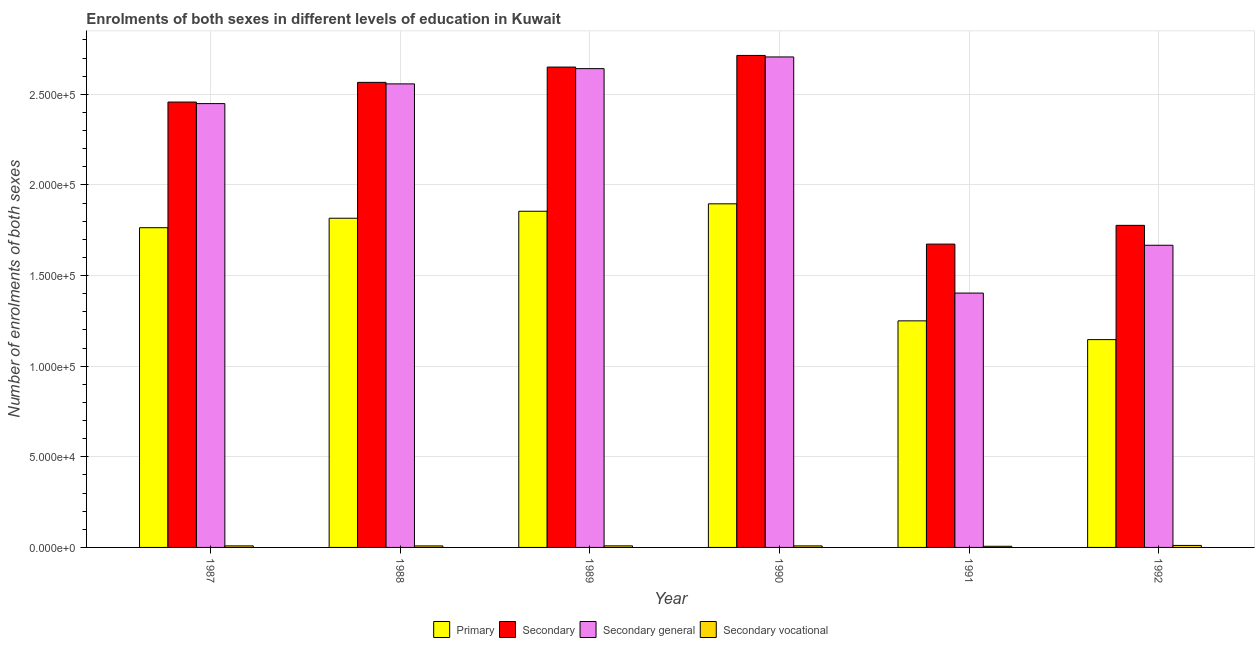Are the number of bars per tick equal to the number of legend labels?
Provide a short and direct response. Yes. What is the label of the 3rd group of bars from the left?
Your answer should be very brief. 1989. What is the number of enrolments in secondary general education in 1992?
Provide a short and direct response. 1.67e+05. Across all years, what is the maximum number of enrolments in secondary education?
Offer a very short reply. 2.71e+05. Across all years, what is the minimum number of enrolments in secondary education?
Keep it short and to the point. 1.67e+05. In which year was the number of enrolments in secondary vocational education maximum?
Your answer should be compact. 1992. In which year was the number of enrolments in secondary vocational education minimum?
Provide a succinct answer. 1991. What is the total number of enrolments in secondary general education in the graph?
Keep it short and to the point. 1.34e+06. What is the difference between the number of enrolments in secondary general education in 1987 and that in 1990?
Your answer should be very brief. -2.57e+04. What is the difference between the number of enrolments in secondary general education in 1991 and the number of enrolments in secondary education in 1987?
Provide a succinct answer. -1.05e+05. What is the average number of enrolments in secondary vocational education per year?
Ensure brevity in your answer.  855.33. What is the ratio of the number of enrolments in secondary vocational education in 1987 to that in 1991?
Provide a short and direct response. 1.35. Is the number of enrolments in secondary general education in 1987 less than that in 1989?
Make the answer very short. Yes. Is the difference between the number of enrolments in secondary education in 1988 and 1989 greater than the difference between the number of enrolments in primary education in 1988 and 1989?
Provide a short and direct response. No. What is the difference between the highest and the second highest number of enrolments in primary education?
Your response must be concise. 4096. What is the difference between the highest and the lowest number of enrolments in secondary education?
Provide a short and direct response. 1.04e+05. Is the sum of the number of enrolments in secondary general education in 1991 and 1992 greater than the maximum number of enrolments in secondary education across all years?
Make the answer very short. Yes. Is it the case that in every year, the sum of the number of enrolments in secondary vocational education and number of enrolments in primary education is greater than the sum of number of enrolments in secondary education and number of enrolments in secondary general education?
Offer a terse response. No. What does the 4th bar from the left in 1992 represents?
Your response must be concise. Secondary vocational. What does the 3rd bar from the right in 1988 represents?
Give a very brief answer. Secondary. Is it the case that in every year, the sum of the number of enrolments in primary education and number of enrolments in secondary education is greater than the number of enrolments in secondary general education?
Make the answer very short. Yes. Are all the bars in the graph horizontal?
Keep it short and to the point. No. What is the title of the graph?
Make the answer very short. Enrolments of both sexes in different levels of education in Kuwait. What is the label or title of the X-axis?
Your response must be concise. Year. What is the label or title of the Y-axis?
Provide a short and direct response. Number of enrolments of both sexes. What is the Number of enrolments of both sexes of Primary in 1987?
Provide a short and direct response. 1.76e+05. What is the Number of enrolments of both sexes of Secondary in 1987?
Give a very brief answer. 2.46e+05. What is the Number of enrolments of both sexes of Secondary general in 1987?
Make the answer very short. 2.45e+05. What is the Number of enrolments of both sexes of Secondary vocational in 1987?
Give a very brief answer. 854. What is the Number of enrolments of both sexes of Primary in 1988?
Your answer should be very brief. 1.82e+05. What is the Number of enrolments of both sexes of Secondary in 1988?
Offer a terse response. 2.57e+05. What is the Number of enrolments of both sexes in Secondary general in 1988?
Offer a terse response. 2.56e+05. What is the Number of enrolments of both sexes in Secondary vocational in 1988?
Make the answer very short. 836. What is the Number of enrolments of both sexes in Primary in 1989?
Offer a very short reply. 1.85e+05. What is the Number of enrolments of both sexes in Secondary in 1989?
Make the answer very short. 2.65e+05. What is the Number of enrolments of both sexes of Secondary general in 1989?
Offer a very short reply. 2.64e+05. What is the Number of enrolments of both sexes of Secondary vocational in 1989?
Your answer should be very brief. 863. What is the Number of enrolments of both sexes of Primary in 1990?
Your answer should be compact. 1.90e+05. What is the Number of enrolments of both sexes in Secondary in 1990?
Provide a short and direct response. 2.71e+05. What is the Number of enrolments of both sexes in Secondary general in 1990?
Provide a succinct answer. 2.71e+05. What is the Number of enrolments of both sexes of Secondary vocational in 1990?
Provide a succinct answer. 842. What is the Number of enrolments of both sexes of Primary in 1991?
Keep it short and to the point. 1.25e+05. What is the Number of enrolments of both sexes of Secondary in 1991?
Your response must be concise. 1.67e+05. What is the Number of enrolments of both sexes of Secondary general in 1991?
Make the answer very short. 1.40e+05. What is the Number of enrolments of both sexes of Secondary vocational in 1991?
Provide a succinct answer. 634. What is the Number of enrolments of both sexes of Primary in 1992?
Offer a terse response. 1.15e+05. What is the Number of enrolments of both sexes of Secondary in 1992?
Make the answer very short. 1.78e+05. What is the Number of enrolments of both sexes of Secondary general in 1992?
Ensure brevity in your answer.  1.67e+05. What is the Number of enrolments of both sexes in Secondary vocational in 1992?
Make the answer very short. 1103. Across all years, what is the maximum Number of enrolments of both sexes in Primary?
Your answer should be compact. 1.90e+05. Across all years, what is the maximum Number of enrolments of both sexes of Secondary?
Give a very brief answer. 2.71e+05. Across all years, what is the maximum Number of enrolments of both sexes in Secondary general?
Your response must be concise. 2.71e+05. Across all years, what is the maximum Number of enrolments of both sexes in Secondary vocational?
Give a very brief answer. 1103. Across all years, what is the minimum Number of enrolments of both sexes of Primary?
Provide a succinct answer. 1.15e+05. Across all years, what is the minimum Number of enrolments of both sexes in Secondary?
Give a very brief answer. 1.67e+05. Across all years, what is the minimum Number of enrolments of both sexes of Secondary general?
Make the answer very short. 1.40e+05. Across all years, what is the minimum Number of enrolments of both sexes in Secondary vocational?
Ensure brevity in your answer.  634. What is the total Number of enrolments of both sexes in Primary in the graph?
Your response must be concise. 9.73e+05. What is the total Number of enrolments of both sexes of Secondary in the graph?
Provide a short and direct response. 1.38e+06. What is the total Number of enrolments of both sexes in Secondary general in the graph?
Your answer should be very brief. 1.34e+06. What is the total Number of enrolments of both sexes in Secondary vocational in the graph?
Make the answer very short. 5132. What is the difference between the Number of enrolments of both sexes of Primary in 1987 and that in 1988?
Keep it short and to the point. -5229. What is the difference between the Number of enrolments of both sexes of Secondary in 1987 and that in 1988?
Offer a very short reply. -1.09e+04. What is the difference between the Number of enrolments of both sexes in Secondary general in 1987 and that in 1988?
Provide a short and direct response. -1.09e+04. What is the difference between the Number of enrolments of both sexes in Secondary vocational in 1987 and that in 1988?
Offer a terse response. 18. What is the difference between the Number of enrolments of both sexes of Primary in 1987 and that in 1989?
Provide a succinct answer. -9086. What is the difference between the Number of enrolments of both sexes in Secondary in 1987 and that in 1989?
Offer a very short reply. -1.93e+04. What is the difference between the Number of enrolments of both sexes in Secondary general in 1987 and that in 1989?
Provide a succinct answer. -1.93e+04. What is the difference between the Number of enrolments of both sexes in Primary in 1987 and that in 1990?
Keep it short and to the point. -1.32e+04. What is the difference between the Number of enrolments of both sexes of Secondary in 1987 and that in 1990?
Your answer should be compact. -2.57e+04. What is the difference between the Number of enrolments of both sexes of Secondary general in 1987 and that in 1990?
Provide a short and direct response. -2.57e+04. What is the difference between the Number of enrolments of both sexes in Secondary vocational in 1987 and that in 1990?
Provide a succinct answer. 12. What is the difference between the Number of enrolments of both sexes in Primary in 1987 and that in 1991?
Make the answer very short. 5.14e+04. What is the difference between the Number of enrolments of both sexes of Secondary in 1987 and that in 1991?
Your response must be concise. 7.84e+04. What is the difference between the Number of enrolments of both sexes in Secondary general in 1987 and that in 1991?
Ensure brevity in your answer.  1.05e+05. What is the difference between the Number of enrolments of both sexes in Secondary vocational in 1987 and that in 1991?
Your answer should be very brief. 220. What is the difference between the Number of enrolments of both sexes of Primary in 1987 and that in 1992?
Ensure brevity in your answer.  6.17e+04. What is the difference between the Number of enrolments of both sexes of Secondary in 1987 and that in 1992?
Ensure brevity in your answer.  6.80e+04. What is the difference between the Number of enrolments of both sexes of Secondary general in 1987 and that in 1992?
Ensure brevity in your answer.  7.81e+04. What is the difference between the Number of enrolments of both sexes of Secondary vocational in 1987 and that in 1992?
Ensure brevity in your answer.  -249. What is the difference between the Number of enrolments of both sexes in Primary in 1988 and that in 1989?
Offer a terse response. -3857. What is the difference between the Number of enrolments of both sexes in Secondary in 1988 and that in 1989?
Offer a terse response. -8443. What is the difference between the Number of enrolments of both sexes in Secondary general in 1988 and that in 1989?
Offer a terse response. -8416. What is the difference between the Number of enrolments of both sexes in Primary in 1988 and that in 1990?
Keep it short and to the point. -7953. What is the difference between the Number of enrolments of both sexes in Secondary in 1988 and that in 1990?
Your answer should be compact. -1.49e+04. What is the difference between the Number of enrolments of both sexes of Secondary general in 1988 and that in 1990?
Ensure brevity in your answer.  -1.49e+04. What is the difference between the Number of enrolments of both sexes in Primary in 1988 and that in 1991?
Your answer should be compact. 5.66e+04. What is the difference between the Number of enrolments of both sexes of Secondary in 1988 and that in 1991?
Ensure brevity in your answer.  8.92e+04. What is the difference between the Number of enrolments of both sexes in Secondary general in 1988 and that in 1991?
Offer a very short reply. 1.15e+05. What is the difference between the Number of enrolments of both sexes of Secondary vocational in 1988 and that in 1991?
Provide a short and direct response. 202. What is the difference between the Number of enrolments of both sexes in Primary in 1988 and that in 1992?
Give a very brief answer. 6.70e+04. What is the difference between the Number of enrolments of both sexes in Secondary in 1988 and that in 1992?
Give a very brief answer. 7.89e+04. What is the difference between the Number of enrolments of both sexes in Secondary general in 1988 and that in 1992?
Offer a terse response. 8.90e+04. What is the difference between the Number of enrolments of both sexes in Secondary vocational in 1988 and that in 1992?
Offer a terse response. -267. What is the difference between the Number of enrolments of both sexes in Primary in 1989 and that in 1990?
Ensure brevity in your answer.  -4096. What is the difference between the Number of enrolments of both sexes in Secondary in 1989 and that in 1990?
Your answer should be compact. -6421. What is the difference between the Number of enrolments of both sexes in Secondary general in 1989 and that in 1990?
Offer a terse response. -6442. What is the difference between the Number of enrolments of both sexes in Secondary vocational in 1989 and that in 1990?
Provide a succinct answer. 21. What is the difference between the Number of enrolments of both sexes in Primary in 1989 and that in 1991?
Ensure brevity in your answer.  6.05e+04. What is the difference between the Number of enrolments of both sexes of Secondary in 1989 and that in 1991?
Make the answer very short. 9.77e+04. What is the difference between the Number of enrolments of both sexes in Secondary general in 1989 and that in 1991?
Your answer should be compact. 1.24e+05. What is the difference between the Number of enrolments of both sexes of Secondary vocational in 1989 and that in 1991?
Offer a very short reply. 229. What is the difference between the Number of enrolments of both sexes in Primary in 1989 and that in 1992?
Your answer should be compact. 7.08e+04. What is the difference between the Number of enrolments of both sexes in Secondary in 1989 and that in 1992?
Make the answer very short. 8.73e+04. What is the difference between the Number of enrolments of both sexes of Secondary general in 1989 and that in 1992?
Offer a terse response. 9.74e+04. What is the difference between the Number of enrolments of both sexes in Secondary vocational in 1989 and that in 1992?
Provide a succinct answer. -240. What is the difference between the Number of enrolments of both sexes of Primary in 1990 and that in 1991?
Offer a terse response. 6.46e+04. What is the difference between the Number of enrolments of both sexes in Secondary in 1990 and that in 1991?
Your response must be concise. 1.04e+05. What is the difference between the Number of enrolments of both sexes in Secondary general in 1990 and that in 1991?
Ensure brevity in your answer.  1.30e+05. What is the difference between the Number of enrolments of both sexes of Secondary vocational in 1990 and that in 1991?
Ensure brevity in your answer.  208. What is the difference between the Number of enrolments of both sexes in Primary in 1990 and that in 1992?
Your response must be concise. 7.49e+04. What is the difference between the Number of enrolments of both sexes of Secondary in 1990 and that in 1992?
Your answer should be very brief. 9.37e+04. What is the difference between the Number of enrolments of both sexes in Secondary general in 1990 and that in 1992?
Your response must be concise. 1.04e+05. What is the difference between the Number of enrolments of both sexes in Secondary vocational in 1990 and that in 1992?
Offer a very short reply. -261. What is the difference between the Number of enrolments of both sexes of Primary in 1991 and that in 1992?
Ensure brevity in your answer.  1.04e+04. What is the difference between the Number of enrolments of both sexes in Secondary in 1991 and that in 1992?
Keep it short and to the point. -1.03e+04. What is the difference between the Number of enrolments of both sexes of Secondary general in 1991 and that in 1992?
Give a very brief answer. -2.64e+04. What is the difference between the Number of enrolments of both sexes of Secondary vocational in 1991 and that in 1992?
Your answer should be compact. -469. What is the difference between the Number of enrolments of both sexes in Primary in 1987 and the Number of enrolments of both sexes in Secondary in 1988?
Your answer should be compact. -8.02e+04. What is the difference between the Number of enrolments of both sexes in Primary in 1987 and the Number of enrolments of both sexes in Secondary general in 1988?
Your answer should be compact. -7.93e+04. What is the difference between the Number of enrolments of both sexes of Primary in 1987 and the Number of enrolments of both sexes of Secondary vocational in 1988?
Give a very brief answer. 1.76e+05. What is the difference between the Number of enrolments of both sexes of Secondary in 1987 and the Number of enrolments of both sexes of Secondary general in 1988?
Ensure brevity in your answer.  -1.00e+04. What is the difference between the Number of enrolments of both sexes of Secondary in 1987 and the Number of enrolments of both sexes of Secondary vocational in 1988?
Offer a very short reply. 2.45e+05. What is the difference between the Number of enrolments of both sexes in Secondary general in 1987 and the Number of enrolments of both sexes in Secondary vocational in 1988?
Offer a terse response. 2.44e+05. What is the difference between the Number of enrolments of both sexes of Primary in 1987 and the Number of enrolments of both sexes of Secondary in 1989?
Make the answer very short. -8.86e+04. What is the difference between the Number of enrolments of both sexes of Primary in 1987 and the Number of enrolments of both sexes of Secondary general in 1989?
Provide a short and direct response. -8.78e+04. What is the difference between the Number of enrolments of both sexes of Primary in 1987 and the Number of enrolments of both sexes of Secondary vocational in 1989?
Ensure brevity in your answer.  1.76e+05. What is the difference between the Number of enrolments of both sexes of Secondary in 1987 and the Number of enrolments of both sexes of Secondary general in 1989?
Offer a terse response. -1.84e+04. What is the difference between the Number of enrolments of both sexes of Secondary in 1987 and the Number of enrolments of both sexes of Secondary vocational in 1989?
Offer a terse response. 2.45e+05. What is the difference between the Number of enrolments of both sexes in Secondary general in 1987 and the Number of enrolments of both sexes in Secondary vocational in 1989?
Provide a short and direct response. 2.44e+05. What is the difference between the Number of enrolments of both sexes in Primary in 1987 and the Number of enrolments of both sexes in Secondary in 1990?
Provide a succinct answer. -9.50e+04. What is the difference between the Number of enrolments of both sexes in Primary in 1987 and the Number of enrolments of both sexes in Secondary general in 1990?
Provide a short and direct response. -9.42e+04. What is the difference between the Number of enrolments of both sexes of Primary in 1987 and the Number of enrolments of both sexes of Secondary vocational in 1990?
Your answer should be very brief. 1.76e+05. What is the difference between the Number of enrolments of both sexes of Secondary in 1987 and the Number of enrolments of both sexes of Secondary general in 1990?
Your answer should be very brief. -2.49e+04. What is the difference between the Number of enrolments of both sexes in Secondary in 1987 and the Number of enrolments of both sexes in Secondary vocational in 1990?
Your answer should be compact. 2.45e+05. What is the difference between the Number of enrolments of both sexes in Secondary general in 1987 and the Number of enrolments of both sexes in Secondary vocational in 1990?
Your response must be concise. 2.44e+05. What is the difference between the Number of enrolments of both sexes in Primary in 1987 and the Number of enrolments of both sexes in Secondary in 1991?
Your response must be concise. 9047. What is the difference between the Number of enrolments of both sexes of Primary in 1987 and the Number of enrolments of both sexes of Secondary general in 1991?
Give a very brief answer. 3.61e+04. What is the difference between the Number of enrolments of both sexes in Primary in 1987 and the Number of enrolments of both sexes in Secondary vocational in 1991?
Your answer should be compact. 1.76e+05. What is the difference between the Number of enrolments of both sexes of Secondary in 1987 and the Number of enrolments of both sexes of Secondary general in 1991?
Give a very brief answer. 1.05e+05. What is the difference between the Number of enrolments of both sexes in Secondary in 1987 and the Number of enrolments of both sexes in Secondary vocational in 1991?
Keep it short and to the point. 2.45e+05. What is the difference between the Number of enrolments of both sexes in Secondary general in 1987 and the Number of enrolments of both sexes in Secondary vocational in 1991?
Make the answer very short. 2.44e+05. What is the difference between the Number of enrolments of both sexes in Primary in 1987 and the Number of enrolments of both sexes in Secondary in 1992?
Provide a succinct answer. -1297. What is the difference between the Number of enrolments of both sexes of Primary in 1987 and the Number of enrolments of both sexes of Secondary general in 1992?
Offer a very short reply. 9681. What is the difference between the Number of enrolments of both sexes of Primary in 1987 and the Number of enrolments of both sexes of Secondary vocational in 1992?
Provide a short and direct response. 1.75e+05. What is the difference between the Number of enrolments of both sexes in Secondary in 1987 and the Number of enrolments of both sexes in Secondary general in 1992?
Ensure brevity in your answer.  7.90e+04. What is the difference between the Number of enrolments of both sexes of Secondary in 1987 and the Number of enrolments of both sexes of Secondary vocational in 1992?
Your answer should be very brief. 2.45e+05. What is the difference between the Number of enrolments of both sexes in Secondary general in 1987 and the Number of enrolments of both sexes in Secondary vocational in 1992?
Give a very brief answer. 2.44e+05. What is the difference between the Number of enrolments of both sexes of Primary in 1988 and the Number of enrolments of both sexes of Secondary in 1989?
Ensure brevity in your answer.  -8.34e+04. What is the difference between the Number of enrolments of both sexes of Primary in 1988 and the Number of enrolments of both sexes of Secondary general in 1989?
Keep it short and to the point. -8.25e+04. What is the difference between the Number of enrolments of both sexes in Primary in 1988 and the Number of enrolments of both sexes in Secondary vocational in 1989?
Make the answer very short. 1.81e+05. What is the difference between the Number of enrolments of both sexes in Secondary in 1988 and the Number of enrolments of both sexes in Secondary general in 1989?
Offer a very short reply. -7580. What is the difference between the Number of enrolments of both sexes of Secondary in 1988 and the Number of enrolments of both sexes of Secondary vocational in 1989?
Provide a succinct answer. 2.56e+05. What is the difference between the Number of enrolments of both sexes in Secondary general in 1988 and the Number of enrolments of both sexes in Secondary vocational in 1989?
Your answer should be compact. 2.55e+05. What is the difference between the Number of enrolments of both sexes of Primary in 1988 and the Number of enrolments of both sexes of Secondary in 1990?
Offer a very short reply. -8.98e+04. What is the difference between the Number of enrolments of both sexes in Primary in 1988 and the Number of enrolments of both sexes in Secondary general in 1990?
Give a very brief answer. -8.90e+04. What is the difference between the Number of enrolments of both sexes of Primary in 1988 and the Number of enrolments of both sexes of Secondary vocational in 1990?
Your response must be concise. 1.81e+05. What is the difference between the Number of enrolments of both sexes of Secondary in 1988 and the Number of enrolments of both sexes of Secondary general in 1990?
Offer a very short reply. -1.40e+04. What is the difference between the Number of enrolments of both sexes in Secondary in 1988 and the Number of enrolments of both sexes in Secondary vocational in 1990?
Provide a short and direct response. 2.56e+05. What is the difference between the Number of enrolments of both sexes in Secondary general in 1988 and the Number of enrolments of both sexes in Secondary vocational in 1990?
Provide a succinct answer. 2.55e+05. What is the difference between the Number of enrolments of both sexes of Primary in 1988 and the Number of enrolments of both sexes of Secondary in 1991?
Make the answer very short. 1.43e+04. What is the difference between the Number of enrolments of both sexes of Primary in 1988 and the Number of enrolments of both sexes of Secondary general in 1991?
Ensure brevity in your answer.  4.13e+04. What is the difference between the Number of enrolments of both sexes in Primary in 1988 and the Number of enrolments of both sexes in Secondary vocational in 1991?
Keep it short and to the point. 1.81e+05. What is the difference between the Number of enrolments of both sexes of Secondary in 1988 and the Number of enrolments of both sexes of Secondary general in 1991?
Offer a very short reply. 1.16e+05. What is the difference between the Number of enrolments of both sexes of Secondary in 1988 and the Number of enrolments of both sexes of Secondary vocational in 1991?
Offer a terse response. 2.56e+05. What is the difference between the Number of enrolments of both sexes in Secondary general in 1988 and the Number of enrolments of both sexes in Secondary vocational in 1991?
Provide a succinct answer. 2.55e+05. What is the difference between the Number of enrolments of both sexes of Primary in 1988 and the Number of enrolments of both sexes of Secondary in 1992?
Your answer should be compact. 3932. What is the difference between the Number of enrolments of both sexes of Primary in 1988 and the Number of enrolments of both sexes of Secondary general in 1992?
Make the answer very short. 1.49e+04. What is the difference between the Number of enrolments of both sexes in Primary in 1988 and the Number of enrolments of both sexes in Secondary vocational in 1992?
Make the answer very short. 1.81e+05. What is the difference between the Number of enrolments of both sexes of Secondary in 1988 and the Number of enrolments of both sexes of Secondary general in 1992?
Your answer should be very brief. 8.99e+04. What is the difference between the Number of enrolments of both sexes of Secondary in 1988 and the Number of enrolments of both sexes of Secondary vocational in 1992?
Provide a succinct answer. 2.55e+05. What is the difference between the Number of enrolments of both sexes of Secondary general in 1988 and the Number of enrolments of both sexes of Secondary vocational in 1992?
Make the answer very short. 2.55e+05. What is the difference between the Number of enrolments of both sexes of Primary in 1989 and the Number of enrolments of both sexes of Secondary in 1990?
Offer a very short reply. -8.60e+04. What is the difference between the Number of enrolments of both sexes of Primary in 1989 and the Number of enrolments of both sexes of Secondary general in 1990?
Provide a short and direct response. -8.51e+04. What is the difference between the Number of enrolments of both sexes of Primary in 1989 and the Number of enrolments of both sexes of Secondary vocational in 1990?
Make the answer very short. 1.85e+05. What is the difference between the Number of enrolments of both sexes in Secondary in 1989 and the Number of enrolments of both sexes in Secondary general in 1990?
Keep it short and to the point. -5579. What is the difference between the Number of enrolments of both sexes in Secondary in 1989 and the Number of enrolments of both sexes in Secondary vocational in 1990?
Offer a terse response. 2.64e+05. What is the difference between the Number of enrolments of both sexes in Secondary general in 1989 and the Number of enrolments of both sexes in Secondary vocational in 1990?
Keep it short and to the point. 2.63e+05. What is the difference between the Number of enrolments of both sexes of Primary in 1989 and the Number of enrolments of both sexes of Secondary in 1991?
Provide a succinct answer. 1.81e+04. What is the difference between the Number of enrolments of both sexes of Primary in 1989 and the Number of enrolments of both sexes of Secondary general in 1991?
Give a very brief answer. 4.51e+04. What is the difference between the Number of enrolments of both sexes of Primary in 1989 and the Number of enrolments of both sexes of Secondary vocational in 1991?
Make the answer very short. 1.85e+05. What is the difference between the Number of enrolments of both sexes in Secondary in 1989 and the Number of enrolments of both sexes in Secondary general in 1991?
Offer a very short reply. 1.25e+05. What is the difference between the Number of enrolments of both sexes of Secondary in 1989 and the Number of enrolments of both sexes of Secondary vocational in 1991?
Your response must be concise. 2.64e+05. What is the difference between the Number of enrolments of both sexes of Secondary general in 1989 and the Number of enrolments of both sexes of Secondary vocational in 1991?
Your response must be concise. 2.64e+05. What is the difference between the Number of enrolments of both sexes of Primary in 1989 and the Number of enrolments of both sexes of Secondary in 1992?
Provide a short and direct response. 7789. What is the difference between the Number of enrolments of both sexes of Primary in 1989 and the Number of enrolments of both sexes of Secondary general in 1992?
Keep it short and to the point. 1.88e+04. What is the difference between the Number of enrolments of both sexes of Primary in 1989 and the Number of enrolments of both sexes of Secondary vocational in 1992?
Offer a very short reply. 1.84e+05. What is the difference between the Number of enrolments of both sexes of Secondary in 1989 and the Number of enrolments of both sexes of Secondary general in 1992?
Provide a succinct answer. 9.83e+04. What is the difference between the Number of enrolments of both sexes in Secondary in 1989 and the Number of enrolments of both sexes in Secondary vocational in 1992?
Provide a short and direct response. 2.64e+05. What is the difference between the Number of enrolments of both sexes of Secondary general in 1989 and the Number of enrolments of both sexes of Secondary vocational in 1992?
Provide a succinct answer. 2.63e+05. What is the difference between the Number of enrolments of both sexes in Primary in 1990 and the Number of enrolments of both sexes in Secondary in 1991?
Provide a succinct answer. 2.22e+04. What is the difference between the Number of enrolments of both sexes in Primary in 1990 and the Number of enrolments of both sexes in Secondary general in 1991?
Your answer should be very brief. 4.92e+04. What is the difference between the Number of enrolments of both sexes in Primary in 1990 and the Number of enrolments of both sexes in Secondary vocational in 1991?
Your answer should be compact. 1.89e+05. What is the difference between the Number of enrolments of both sexes in Secondary in 1990 and the Number of enrolments of both sexes in Secondary general in 1991?
Ensure brevity in your answer.  1.31e+05. What is the difference between the Number of enrolments of both sexes of Secondary in 1990 and the Number of enrolments of both sexes of Secondary vocational in 1991?
Your answer should be very brief. 2.71e+05. What is the difference between the Number of enrolments of both sexes in Secondary general in 1990 and the Number of enrolments of both sexes in Secondary vocational in 1991?
Ensure brevity in your answer.  2.70e+05. What is the difference between the Number of enrolments of both sexes of Primary in 1990 and the Number of enrolments of both sexes of Secondary in 1992?
Provide a short and direct response. 1.19e+04. What is the difference between the Number of enrolments of both sexes in Primary in 1990 and the Number of enrolments of both sexes in Secondary general in 1992?
Give a very brief answer. 2.29e+04. What is the difference between the Number of enrolments of both sexes of Primary in 1990 and the Number of enrolments of both sexes of Secondary vocational in 1992?
Your answer should be compact. 1.88e+05. What is the difference between the Number of enrolments of both sexes in Secondary in 1990 and the Number of enrolments of both sexes in Secondary general in 1992?
Offer a terse response. 1.05e+05. What is the difference between the Number of enrolments of both sexes of Secondary in 1990 and the Number of enrolments of both sexes of Secondary vocational in 1992?
Give a very brief answer. 2.70e+05. What is the difference between the Number of enrolments of both sexes of Secondary general in 1990 and the Number of enrolments of both sexes of Secondary vocational in 1992?
Offer a terse response. 2.69e+05. What is the difference between the Number of enrolments of both sexes in Primary in 1991 and the Number of enrolments of both sexes in Secondary in 1992?
Provide a succinct answer. -5.27e+04. What is the difference between the Number of enrolments of both sexes of Primary in 1991 and the Number of enrolments of both sexes of Secondary general in 1992?
Provide a succinct answer. -4.17e+04. What is the difference between the Number of enrolments of both sexes in Primary in 1991 and the Number of enrolments of both sexes in Secondary vocational in 1992?
Keep it short and to the point. 1.24e+05. What is the difference between the Number of enrolments of both sexes in Secondary in 1991 and the Number of enrolments of both sexes in Secondary general in 1992?
Make the answer very short. 634. What is the difference between the Number of enrolments of both sexes of Secondary in 1991 and the Number of enrolments of both sexes of Secondary vocational in 1992?
Your answer should be compact. 1.66e+05. What is the difference between the Number of enrolments of both sexes in Secondary general in 1991 and the Number of enrolments of both sexes in Secondary vocational in 1992?
Keep it short and to the point. 1.39e+05. What is the average Number of enrolments of both sexes of Primary per year?
Keep it short and to the point. 1.62e+05. What is the average Number of enrolments of both sexes of Secondary per year?
Provide a succinct answer. 2.31e+05. What is the average Number of enrolments of both sexes in Secondary general per year?
Your answer should be very brief. 2.24e+05. What is the average Number of enrolments of both sexes of Secondary vocational per year?
Keep it short and to the point. 855.33. In the year 1987, what is the difference between the Number of enrolments of both sexes of Primary and Number of enrolments of both sexes of Secondary?
Offer a terse response. -6.93e+04. In the year 1987, what is the difference between the Number of enrolments of both sexes of Primary and Number of enrolments of both sexes of Secondary general?
Your answer should be compact. -6.85e+04. In the year 1987, what is the difference between the Number of enrolments of both sexes of Primary and Number of enrolments of both sexes of Secondary vocational?
Offer a very short reply. 1.76e+05. In the year 1987, what is the difference between the Number of enrolments of both sexes in Secondary and Number of enrolments of both sexes in Secondary general?
Ensure brevity in your answer.  854. In the year 1987, what is the difference between the Number of enrolments of both sexes of Secondary and Number of enrolments of both sexes of Secondary vocational?
Ensure brevity in your answer.  2.45e+05. In the year 1987, what is the difference between the Number of enrolments of both sexes of Secondary general and Number of enrolments of both sexes of Secondary vocational?
Your answer should be compact. 2.44e+05. In the year 1988, what is the difference between the Number of enrolments of both sexes of Primary and Number of enrolments of both sexes of Secondary?
Offer a terse response. -7.50e+04. In the year 1988, what is the difference between the Number of enrolments of both sexes in Primary and Number of enrolments of both sexes in Secondary general?
Offer a terse response. -7.41e+04. In the year 1988, what is the difference between the Number of enrolments of both sexes in Primary and Number of enrolments of both sexes in Secondary vocational?
Ensure brevity in your answer.  1.81e+05. In the year 1988, what is the difference between the Number of enrolments of both sexes in Secondary and Number of enrolments of both sexes in Secondary general?
Make the answer very short. 836. In the year 1988, what is the difference between the Number of enrolments of both sexes of Secondary and Number of enrolments of both sexes of Secondary vocational?
Keep it short and to the point. 2.56e+05. In the year 1988, what is the difference between the Number of enrolments of both sexes in Secondary general and Number of enrolments of both sexes in Secondary vocational?
Give a very brief answer. 2.55e+05. In the year 1989, what is the difference between the Number of enrolments of both sexes of Primary and Number of enrolments of both sexes of Secondary?
Your answer should be compact. -7.95e+04. In the year 1989, what is the difference between the Number of enrolments of both sexes of Primary and Number of enrolments of both sexes of Secondary general?
Your response must be concise. -7.87e+04. In the year 1989, what is the difference between the Number of enrolments of both sexes of Primary and Number of enrolments of both sexes of Secondary vocational?
Offer a terse response. 1.85e+05. In the year 1989, what is the difference between the Number of enrolments of both sexes in Secondary and Number of enrolments of both sexes in Secondary general?
Give a very brief answer. 863. In the year 1989, what is the difference between the Number of enrolments of both sexes of Secondary and Number of enrolments of both sexes of Secondary vocational?
Offer a very short reply. 2.64e+05. In the year 1989, what is the difference between the Number of enrolments of both sexes in Secondary general and Number of enrolments of both sexes in Secondary vocational?
Your answer should be compact. 2.63e+05. In the year 1990, what is the difference between the Number of enrolments of both sexes of Primary and Number of enrolments of both sexes of Secondary?
Ensure brevity in your answer.  -8.19e+04. In the year 1990, what is the difference between the Number of enrolments of both sexes in Primary and Number of enrolments of both sexes in Secondary general?
Offer a very short reply. -8.10e+04. In the year 1990, what is the difference between the Number of enrolments of both sexes in Primary and Number of enrolments of both sexes in Secondary vocational?
Offer a terse response. 1.89e+05. In the year 1990, what is the difference between the Number of enrolments of both sexes in Secondary and Number of enrolments of both sexes in Secondary general?
Your answer should be very brief. 842. In the year 1990, what is the difference between the Number of enrolments of both sexes of Secondary and Number of enrolments of both sexes of Secondary vocational?
Keep it short and to the point. 2.71e+05. In the year 1990, what is the difference between the Number of enrolments of both sexes of Secondary general and Number of enrolments of both sexes of Secondary vocational?
Offer a very short reply. 2.70e+05. In the year 1991, what is the difference between the Number of enrolments of both sexes of Primary and Number of enrolments of both sexes of Secondary?
Offer a terse response. -4.23e+04. In the year 1991, what is the difference between the Number of enrolments of both sexes in Primary and Number of enrolments of both sexes in Secondary general?
Offer a very short reply. -1.53e+04. In the year 1991, what is the difference between the Number of enrolments of both sexes of Primary and Number of enrolments of both sexes of Secondary vocational?
Keep it short and to the point. 1.24e+05. In the year 1991, what is the difference between the Number of enrolments of both sexes in Secondary and Number of enrolments of both sexes in Secondary general?
Keep it short and to the point. 2.70e+04. In the year 1991, what is the difference between the Number of enrolments of both sexes of Secondary and Number of enrolments of both sexes of Secondary vocational?
Your response must be concise. 1.67e+05. In the year 1991, what is the difference between the Number of enrolments of both sexes of Secondary general and Number of enrolments of both sexes of Secondary vocational?
Keep it short and to the point. 1.40e+05. In the year 1992, what is the difference between the Number of enrolments of both sexes in Primary and Number of enrolments of both sexes in Secondary?
Your answer should be compact. -6.30e+04. In the year 1992, what is the difference between the Number of enrolments of both sexes of Primary and Number of enrolments of both sexes of Secondary general?
Keep it short and to the point. -5.21e+04. In the year 1992, what is the difference between the Number of enrolments of both sexes of Primary and Number of enrolments of both sexes of Secondary vocational?
Provide a short and direct response. 1.14e+05. In the year 1992, what is the difference between the Number of enrolments of both sexes in Secondary and Number of enrolments of both sexes in Secondary general?
Your answer should be compact. 1.10e+04. In the year 1992, what is the difference between the Number of enrolments of both sexes in Secondary and Number of enrolments of both sexes in Secondary vocational?
Provide a succinct answer. 1.77e+05. In the year 1992, what is the difference between the Number of enrolments of both sexes of Secondary general and Number of enrolments of both sexes of Secondary vocational?
Ensure brevity in your answer.  1.66e+05. What is the ratio of the Number of enrolments of both sexes in Primary in 1987 to that in 1988?
Offer a very short reply. 0.97. What is the ratio of the Number of enrolments of both sexes of Secondary in 1987 to that in 1988?
Ensure brevity in your answer.  0.96. What is the ratio of the Number of enrolments of both sexes of Secondary general in 1987 to that in 1988?
Provide a short and direct response. 0.96. What is the ratio of the Number of enrolments of both sexes of Secondary vocational in 1987 to that in 1988?
Provide a short and direct response. 1.02. What is the ratio of the Number of enrolments of both sexes in Primary in 1987 to that in 1989?
Offer a very short reply. 0.95. What is the ratio of the Number of enrolments of both sexes of Secondary in 1987 to that in 1989?
Keep it short and to the point. 0.93. What is the ratio of the Number of enrolments of both sexes of Secondary general in 1987 to that in 1989?
Make the answer very short. 0.93. What is the ratio of the Number of enrolments of both sexes of Secondary vocational in 1987 to that in 1989?
Offer a very short reply. 0.99. What is the ratio of the Number of enrolments of both sexes in Primary in 1987 to that in 1990?
Your response must be concise. 0.93. What is the ratio of the Number of enrolments of both sexes in Secondary in 1987 to that in 1990?
Ensure brevity in your answer.  0.91. What is the ratio of the Number of enrolments of both sexes of Secondary general in 1987 to that in 1990?
Give a very brief answer. 0.9. What is the ratio of the Number of enrolments of both sexes in Secondary vocational in 1987 to that in 1990?
Your response must be concise. 1.01. What is the ratio of the Number of enrolments of both sexes in Primary in 1987 to that in 1991?
Keep it short and to the point. 1.41. What is the ratio of the Number of enrolments of both sexes of Secondary in 1987 to that in 1991?
Make the answer very short. 1.47. What is the ratio of the Number of enrolments of both sexes of Secondary general in 1987 to that in 1991?
Offer a very short reply. 1.74. What is the ratio of the Number of enrolments of both sexes of Secondary vocational in 1987 to that in 1991?
Provide a short and direct response. 1.35. What is the ratio of the Number of enrolments of both sexes of Primary in 1987 to that in 1992?
Your answer should be compact. 1.54. What is the ratio of the Number of enrolments of both sexes in Secondary in 1987 to that in 1992?
Provide a succinct answer. 1.38. What is the ratio of the Number of enrolments of both sexes in Secondary general in 1987 to that in 1992?
Provide a short and direct response. 1.47. What is the ratio of the Number of enrolments of both sexes of Secondary vocational in 1987 to that in 1992?
Give a very brief answer. 0.77. What is the ratio of the Number of enrolments of both sexes of Primary in 1988 to that in 1989?
Give a very brief answer. 0.98. What is the ratio of the Number of enrolments of both sexes of Secondary in 1988 to that in 1989?
Provide a succinct answer. 0.97. What is the ratio of the Number of enrolments of both sexes in Secondary general in 1988 to that in 1989?
Your answer should be compact. 0.97. What is the ratio of the Number of enrolments of both sexes of Secondary vocational in 1988 to that in 1989?
Your answer should be compact. 0.97. What is the ratio of the Number of enrolments of both sexes in Primary in 1988 to that in 1990?
Ensure brevity in your answer.  0.96. What is the ratio of the Number of enrolments of both sexes in Secondary in 1988 to that in 1990?
Make the answer very short. 0.95. What is the ratio of the Number of enrolments of both sexes in Secondary general in 1988 to that in 1990?
Ensure brevity in your answer.  0.95. What is the ratio of the Number of enrolments of both sexes in Primary in 1988 to that in 1991?
Provide a short and direct response. 1.45. What is the ratio of the Number of enrolments of both sexes in Secondary in 1988 to that in 1991?
Ensure brevity in your answer.  1.53. What is the ratio of the Number of enrolments of both sexes of Secondary general in 1988 to that in 1991?
Keep it short and to the point. 1.82. What is the ratio of the Number of enrolments of both sexes of Secondary vocational in 1988 to that in 1991?
Your response must be concise. 1.32. What is the ratio of the Number of enrolments of both sexes of Primary in 1988 to that in 1992?
Give a very brief answer. 1.58. What is the ratio of the Number of enrolments of both sexes of Secondary in 1988 to that in 1992?
Offer a very short reply. 1.44. What is the ratio of the Number of enrolments of both sexes in Secondary general in 1988 to that in 1992?
Offer a terse response. 1.53. What is the ratio of the Number of enrolments of both sexes in Secondary vocational in 1988 to that in 1992?
Your answer should be compact. 0.76. What is the ratio of the Number of enrolments of both sexes in Primary in 1989 to that in 1990?
Your answer should be very brief. 0.98. What is the ratio of the Number of enrolments of both sexes of Secondary in 1989 to that in 1990?
Your answer should be very brief. 0.98. What is the ratio of the Number of enrolments of both sexes in Secondary general in 1989 to that in 1990?
Offer a very short reply. 0.98. What is the ratio of the Number of enrolments of both sexes in Secondary vocational in 1989 to that in 1990?
Offer a very short reply. 1.02. What is the ratio of the Number of enrolments of both sexes in Primary in 1989 to that in 1991?
Provide a short and direct response. 1.48. What is the ratio of the Number of enrolments of both sexes of Secondary in 1989 to that in 1991?
Give a very brief answer. 1.58. What is the ratio of the Number of enrolments of both sexes in Secondary general in 1989 to that in 1991?
Your response must be concise. 1.88. What is the ratio of the Number of enrolments of both sexes in Secondary vocational in 1989 to that in 1991?
Provide a short and direct response. 1.36. What is the ratio of the Number of enrolments of both sexes of Primary in 1989 to that in 1992?
Provide a succinct answer. 1.62. What is the ratio of the Number of enrolments of both sexes of Secondary in 1989 to that in 1992?
Your answer should be very brief. 1.49. What is the ratio of the Number of enrolments of both sexes in Secondary general in 1989 to that in 1992?
Offer a terse response. 1.58. What is the ratio of the Number of enrolments of both sexes in Secondary vocational in 1989 to that in 1992?
Give a very brief answer. 0.78. What is the ratio of the Number of enrolments of both sexes of Primary in 1990 to that in 1991?
Offer a very short reply. 1.52. What is the ratio of the Number of enrolments of both sexes in Secondary in 1990 to that in 1991?
Your answer should be very brief. 1.62. What is the ratio of the Number of enrolments of both sexes in Secondary general in 1990 to that in 1991?
Provide a short and direct response. 1.93. What is the ratio of the Number of enrolments of both sexes in Secondary vocational in 1990 to that in 1991?
Your answer should be compact. 1.33. What is the ratio of the Number of enrolments of both sexes of Primary in 1990 to that in 1992?
Provide a short and direct response. 1.65. What is the ratio of the Number of enrolments of both sexes of Secondary in 1990 to that in 1992?
Your answer should be compact. 1.53. What is the ratio of the Number of enrolments of both sexes of Secondary general in 1990 to that in 1992?
Offer a terse response. 1.62. What is the ratio of the Number of enrolments of both sexes in Secondary vocational in 1990 to that in 1992?
Your response must be concise. 0.76. What is the ratio of the Number of enrolments of both sexes of Primary in 1991 to that in 1992?
Your answer should be compact. 1.09. What is the ratio of the Number of enrolments of both sexes in Secondary in 1991 to that in 1992?
Ensure brevity in your answer.  0.94. What is the ratio of the Number of enrolments of both sexes in Secondary general in 1991 to that in 1992?
Ensure brevity in your answer.  0.84. What is the ratio of the Number of enrolments of both sexes in Secondary vocational in 1991 to that in 1992?
Offer a terse response. 0.57. What is the difference between the highest and the second highest Number of enrolments of both sexes of Primary?
Your answer should be very brief. 4096. What is the difference between the highest and the second highest Number of enrolments of both sexes of Secondary?
Offer a very short reply. 6421. What is the difference between the highest and the second highest Number of enrolments of both sexes in Secondary general?
Provide a succinct answer. 6442. What is the difference between the highest and the second highest Number of enrolments of both sexes in Secondary vocational?
Give a very brief answer. 240. What is the difference between the highest and the lowest Number of enrolments of both sexes of Primary?
Ensure brevity in your answer.  7.49e+04. What is the difference between the highest and the lowest Number of enrolments of both sexes of Secondary?
Keep it short and to the point. 1.04e+05. What is the difference between the highest and the lowest Number of enrolments of both sexes of Secondary general?
Your answer should be compact. 1.30e+05. What is the difference between the highest and the lowest Number of enrolments of both sexes in Secondary vocational?
Your answer should be compact. 469. 